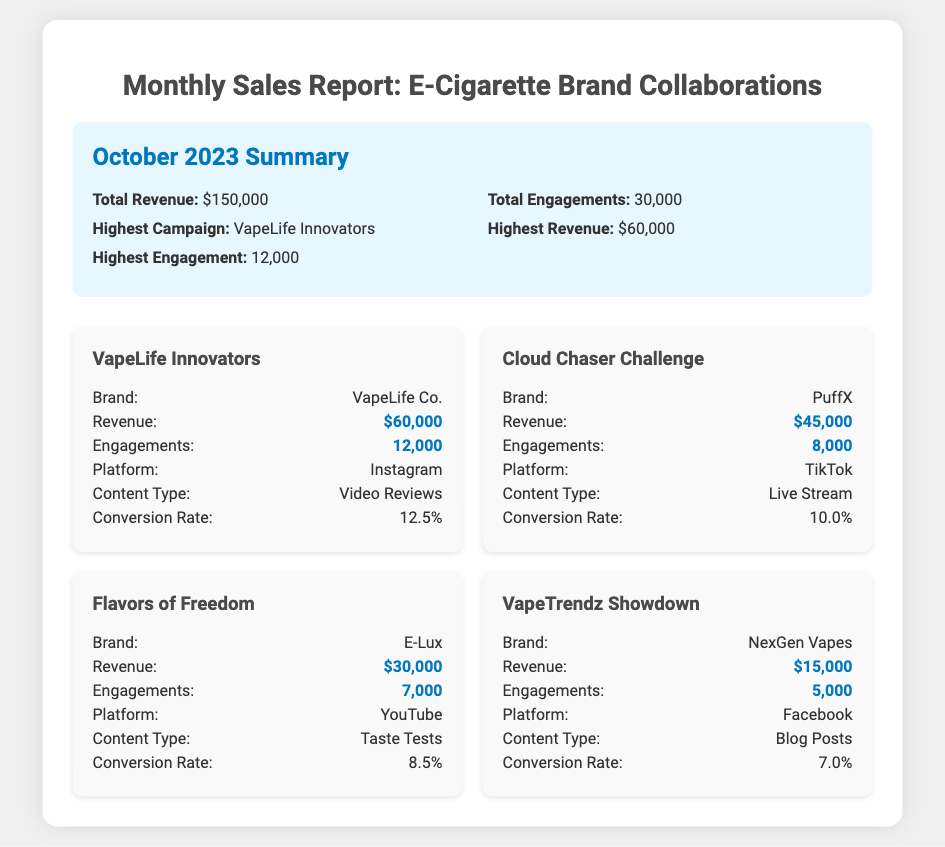What is the total revenue? The total revenue is provided in the summary section of the document, which states a total of $150,000.
Answer: $150,000 Which campaign had the highest revenue? The campaign with the highest revenue is mentioned specifically in the summary section, which is VapeLife Innovators with a revenue of $60,000.
Answer: VapeLife Innovators How many total engagements were there? The total engagements are listed in the summary section of the document, which indicates 30,000 engagements.
Answer: 30,000 What is the conversion rate for the Cloud Chaser Challenge? The conversion rate for the Cloud Chaser Challenge is explicitly provided in the campaign card details for that specific campaign, which is 10.0%.
Answer: 10.0% Which platform had the highest engagement? By comparing the engagement numbers across all campaigns, VapeLife Innovators had the highest engagements with 12,000, indicating that Instagram has the highest engagement for this document.
Answer: Instagram How many engagements did the Flavors of Freedom campaign generate? The number of engagements for the Flavors of Freedom campaign is identified in the campaign details as 7,000 engagements.
Answer: 7,000 What content type was used in the VapeTrendz Showdown? The content type for the VapeTrendz Showdown is mentioned in the campaign card as Blog Posts.
Answer: Blog Posts Which campaign's brand is PuffX? The brand for the Cloud Chaser Challenge campaign, which is a specific campaign, is PuffX, as stated in the campaign card.
Answer: PuffX How much revenue did the Flavors of Freedom campaign generate? The revenue for the Flavors of Freedom campaign is noted in the document's campaign details as $30,000.
Answer: $30,000 